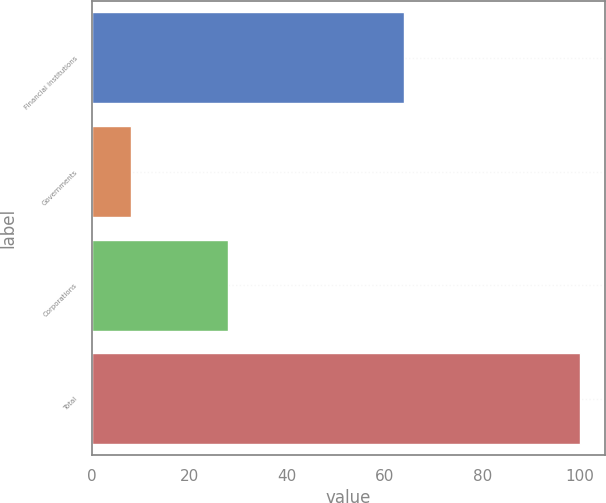Convert chart. <chart><loc_0><loc_0><loc_500><loc_500><bar_chart><fcel>Financial institutions<fcel>Governments<fcel>Corporations<fcel>Total<nl><fcel>64<fcel>8<fcel>28<fcel>100<nl></chart> 